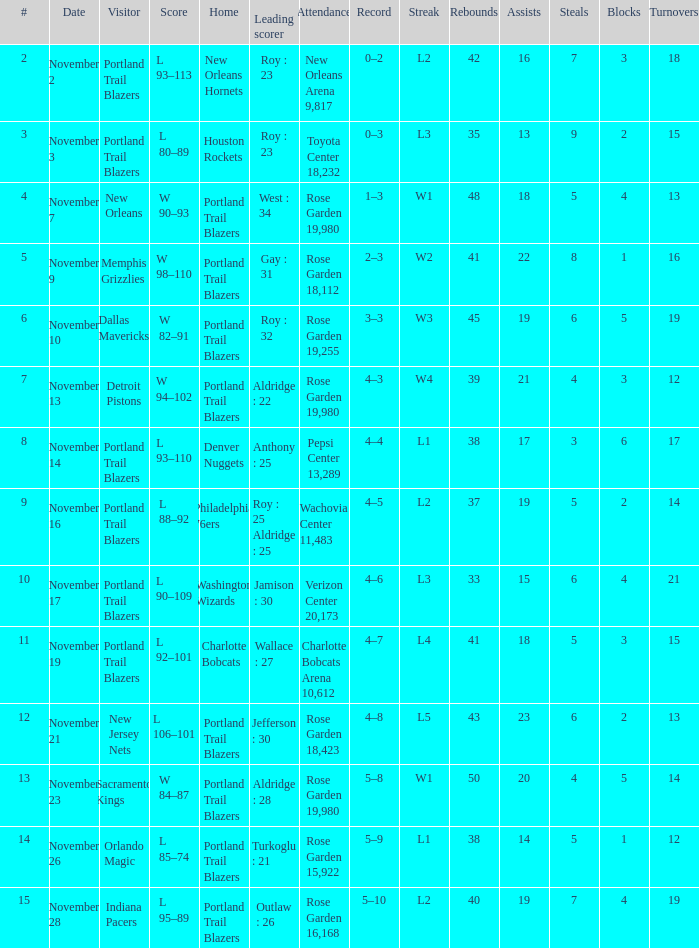What is the total number of date where visitor is new jersey nets 1.0. 